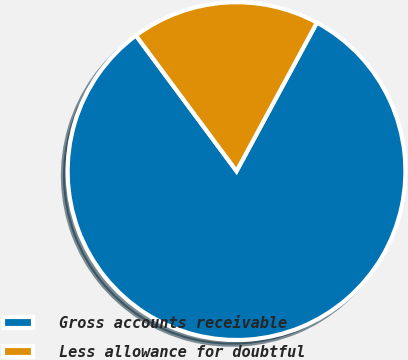<chart> <loc_0><loc_0><loc_500><loc_500><pie_chart><fcel>Gross accounts receivable<fcel>Less allowance for doubtful<nl><fcel>81.95%<fcel>18.05%<nl></chart> 